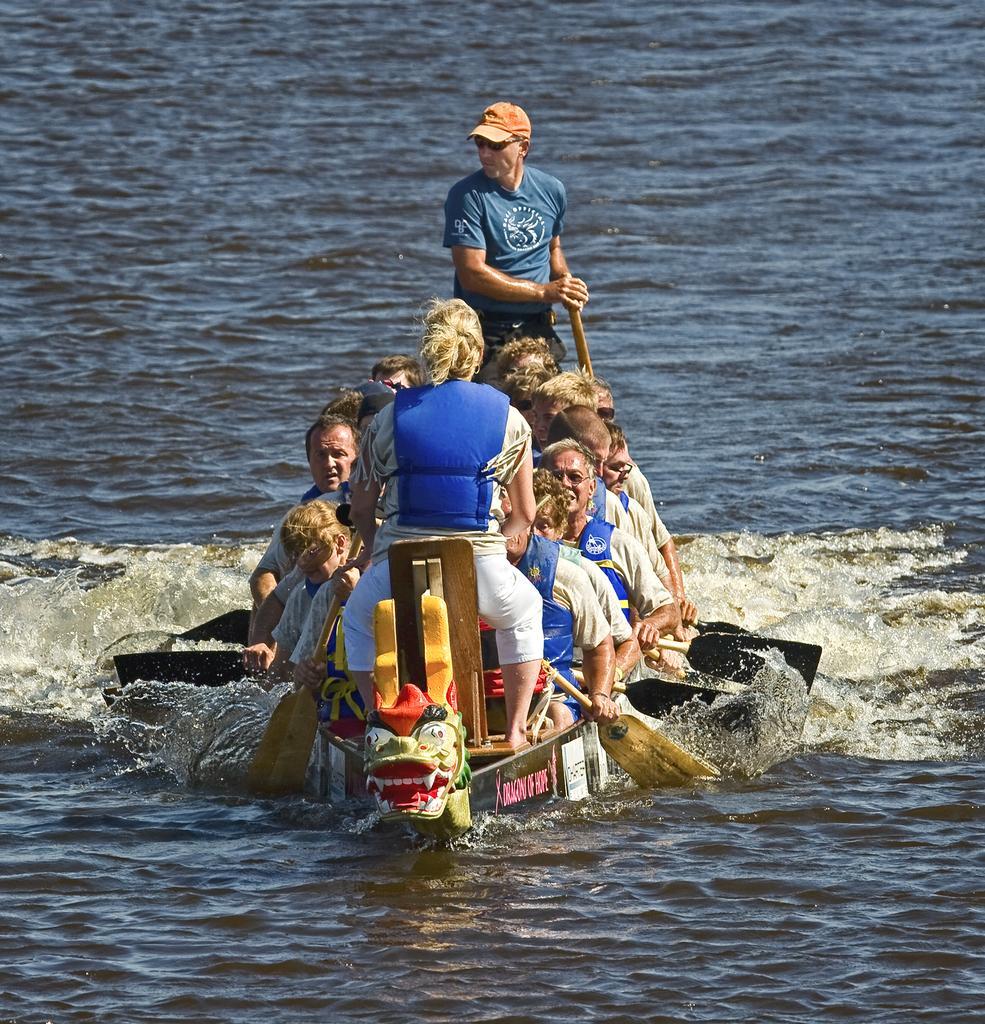Describe this image in one or two sentences. In this image in the center there are persons sitting in the boat and rowing. In the background there is an ocean. 